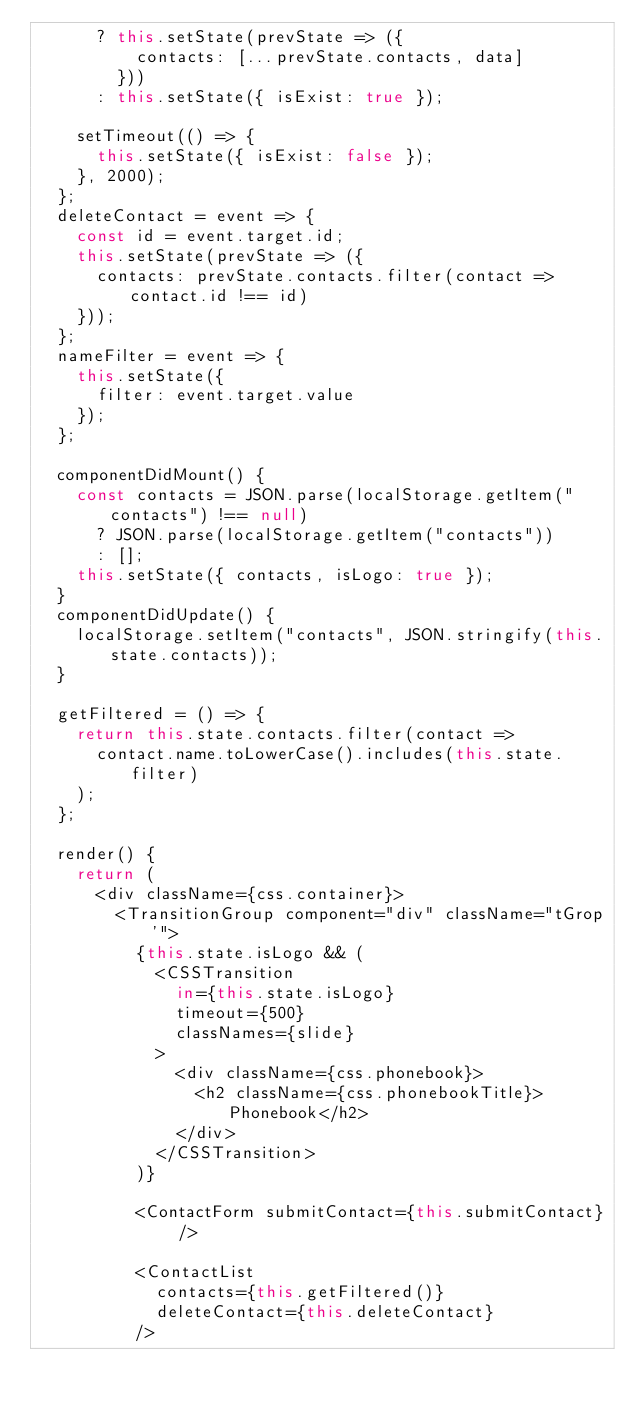<code> <loc_0><loc_0><loc_500><loc_500><_JavaScript_>      ? this.setState(prevState => ({
          contacts: [...prevState.contacts, data]
        }))
      : this.setState({ isExist: true });
         
    setTimeout(() => {
      this.setState({ isExist: false });
    }, 2000);
  };
  deleteContact = event => {
    const id = event.target.id;
    this.setState(prevState => ({
      contacts: prevState.contacts.filter(contact => contact.id !== id)
    }));
  };
  nameFilter = event => {
    this.setState({
      filter: event.target.value
    });
  };

  componentDidMount() {
    const contacts = JSON.parse(localStorage.getItem("contacts") !== null)
      ? JSON.parse(localStorage.getItem("contacts"))
      : [];
    this.setState({ contacts, isLogo: true });
  }
  componentDidUpdate() {
    localStorage.setItem("contacts", JSON.stringify(this.state.contacts));
  }

  getFiltered = () => {
    return this.state.contacts.filter(contact =>
      contact.name.toLowerCase().includes(this.state.filter)
    );
  };

  render() {
    return (
      <div className={css.container}>
        <TransitionGroup component="div" className="tGrop'">
          {this.state.isLogo && (
            <CSSTransition
              in={this.state.isLogo}
              timeout={500}
              classNames={slide}
            >
              <div className={css.phonebook}>
                <h2 className={css.phonebookTitle}> Phonebook</h2>
              </div>
            </CSSTransition>
          )}

          <ContactForm submitContact={this.submitContact} />
            
          <ContactList
            contacts={this.getFiltered()}
            deleteContact={this.deleteContact}
          />
         
        </code> 